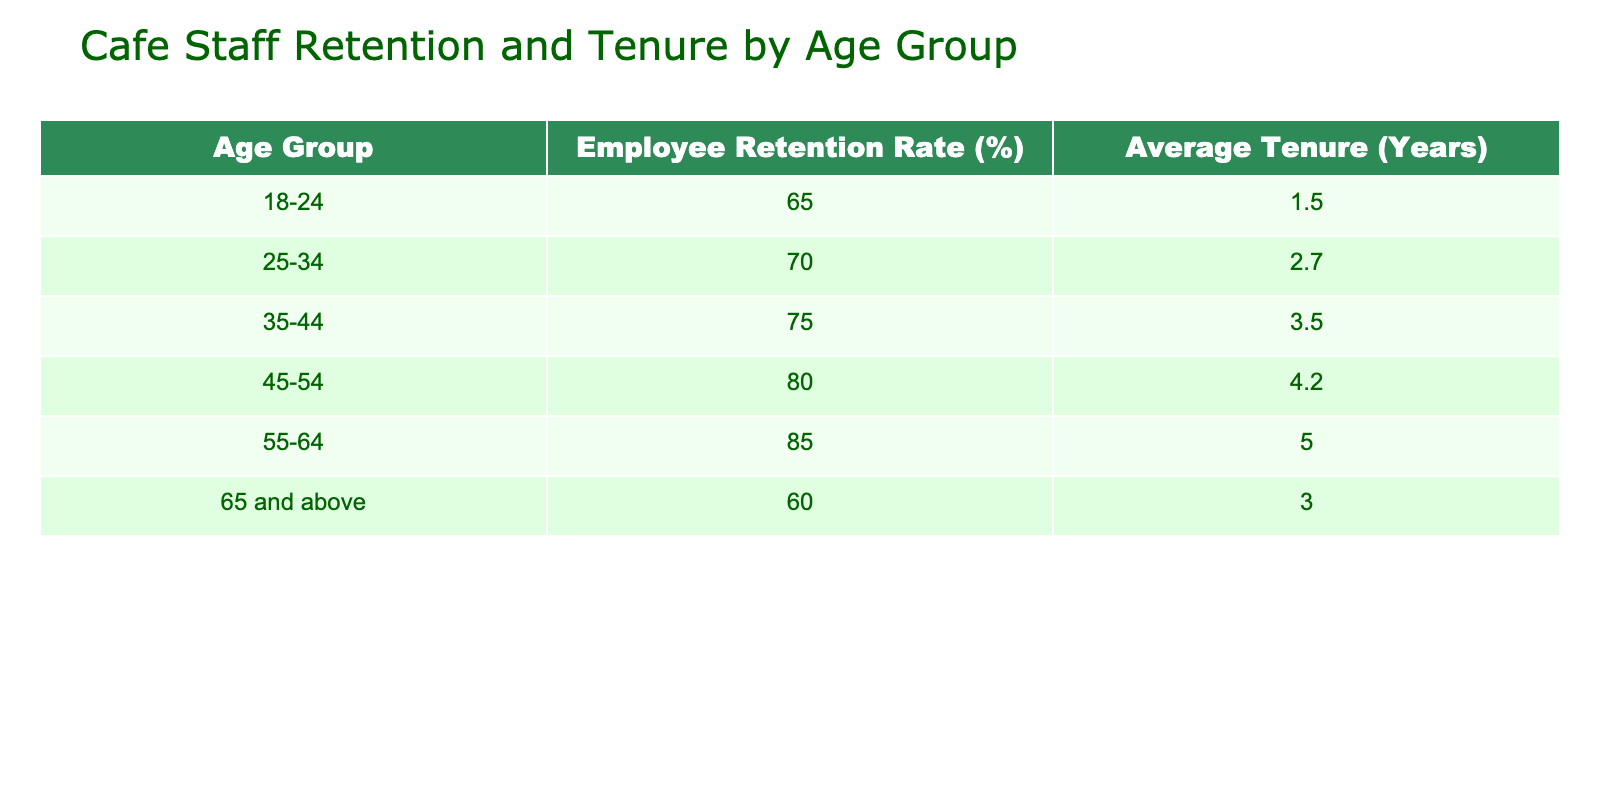What is the employee retention rate for the age group 25-34? The retention rate for the age group 25-34 is given directly in the table, which states 70%.
Answer: 70% Which age group has the highest average tenure? By comparing the "Average Tenure (Years)" column, 55-64 has the highest value of 5.0 years.
Answer: 55-64 What is the average employee retention rate of all age groups combined? To find the average, sum all retention rates: (65 + 70 + 75 + 80 + 85 + 60) = 435. Then divide by the number of age groups, which is 6: 435 / 6 = 72.5%.
Answer: 72.5% Is the employee retention rate for the age group 65 and above higher than that of 18-24? The table shows the retention rate for 65 and above is 60% and for 18-24 it is 65%. Since 65% is greater than 60%, the statement is false.
Answer: No If you combine the employee retention rates for age groups 25-34 and 35-44, what percentage is that? The retention rates are 70% and 75%. Adding them gives 70 + 75 = 145%.
Answer: 145% Which age group has both the lowest employee retention rate and the shortest average tenure? The age group 18-24 has the lowest retention rate of 65% and the shortest average tenure of 1.5 years according to the table.
Answer: 18-24 What is the difference in average tenure between the age groups 45-54 and 55-64? The average tenure for 45-54 is 4.2 years and for 55-64 is 5.0 years. The difference is 5.0 - 4.2 = 0.8 years.
Answer: 0.8 years Are there more age groups with retention rates above 75% than those below? The groups above 75% are 35-44 (75%), 45-54 (80%), and 55-64 (85%) which totals 3. The groups below are 18-24 (65%) and 65 and above (60%) which totals 2. Since 3 is greater than 2, the answer is yes.
Answer: Yes What is the total tenure of all age groups combined? Sum the average tenures: 1.5 + 2.7 + 3.5 + 4.2 + 5.0 + 3.0 = 20.9 years.
Answer: 20.9 years 